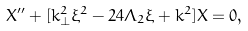Convert formula to latex. <formula><loc_0><loc_0><loc_500><loc_500>X ^ { \prime \prime } + [ k _ { \perp } ^ { 2 } \xi ^ { 2 } - 2 4 \Lambda _ { 2 } \xi + k ^ { 2 } ] X = 0 ,</formula> 